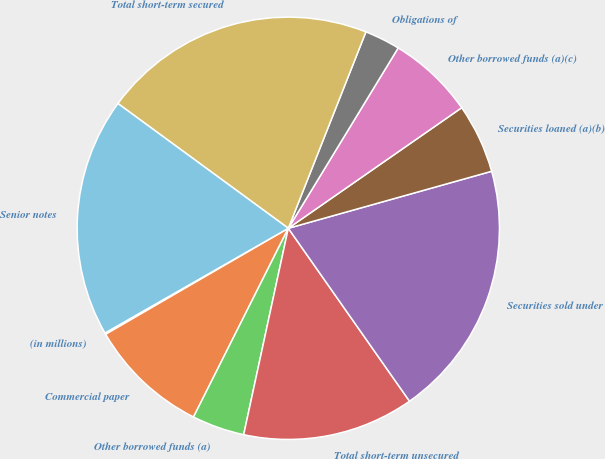Convert chart. <chart><loc_0><loc_0><loc_500><loc_500><pie_chart><fcel>(in millions)<fcel>Commercial paper<fcel>Other borrowed funds (a)<fcel>Total short-term unsecured<fcel>Securities sold under<fcel>Securities loaned (a)(b)<fcel>Other borrowed funds (a)(c)<fcel>Obligations of<fcel>Total short-term secured<fcel>Senior notes<nl><fcel>0.11%<fcel>9.22%<fcel>4.02%<fcel>13.12%<fcel>19.62%<fcel>5.32%<fcel>6.62%<fcel>2.72%<fcel>20.93%<fcel>18.32%<nl></chart> 